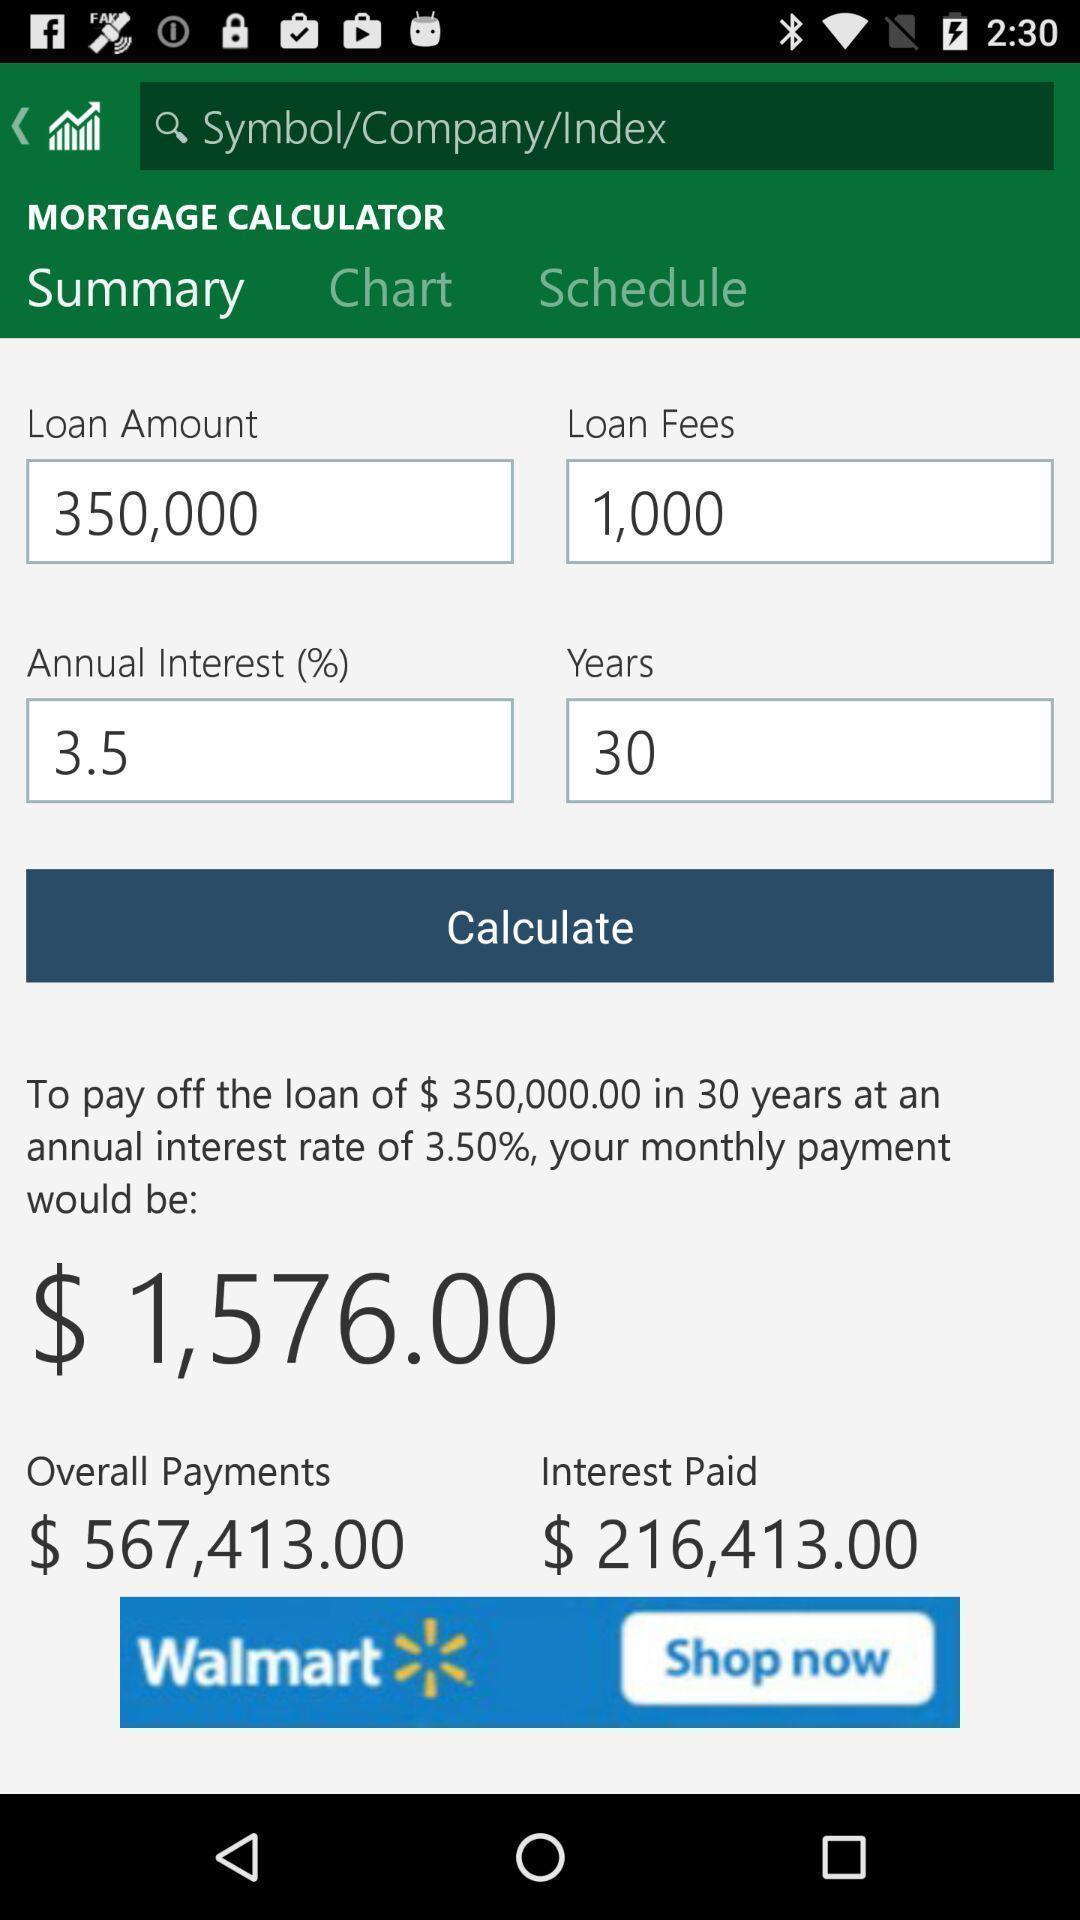Provide a description of this screenshot. Summary of the loan amount details on finance app. 